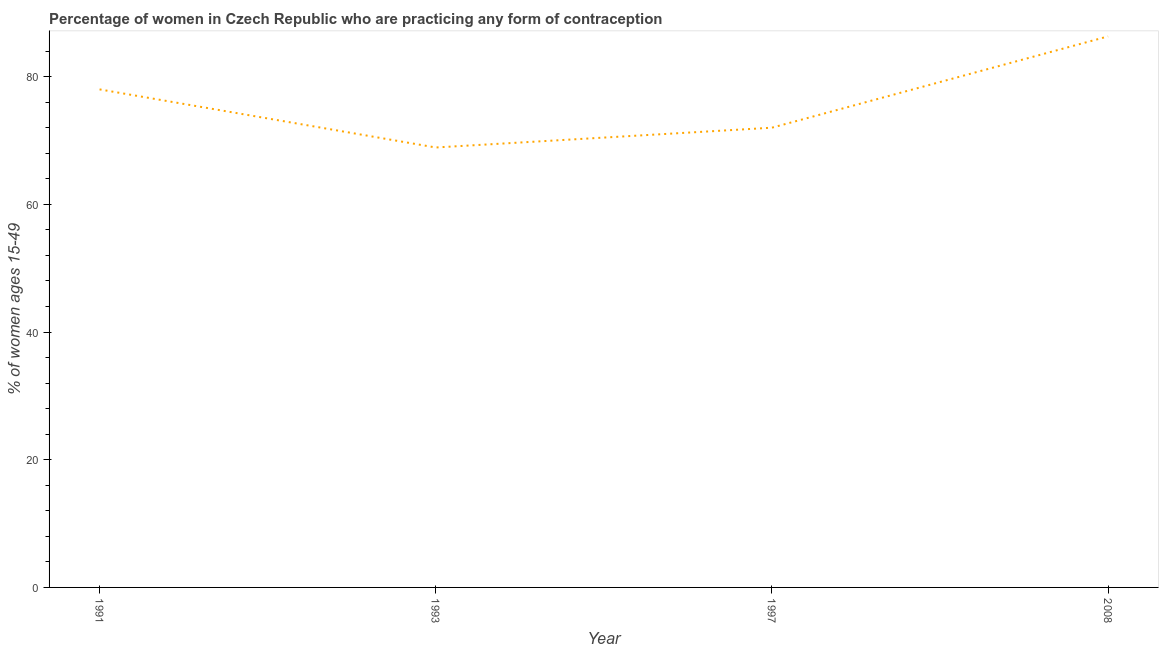What is the contraceptive prevalence in 1993?
Provide a short and direct response. 68.9. Across all years, what is the maximum contraceptive prevalence?
Ensure brevity in your answer.  86.3. Across all years, what is the minimum contraceptive prevalence?
Provide a short and direct response. 68.9. In which year was the contraceptive prevalence maximum?
Provide a short and direct response. 2008. What is the sum of the contraceptive prevalence?
Provide a succinct answer. 305.2. What is the average contraceptive prevalence per year?
Ensure brevity in your answer.  76.3. What is the median contraceptive prevalence?
Give a very brief answer. 75. Do a majority of the years between 1993 and 2008 (inclusive) have contraceptive prevalence greater than 24 %?
Your answer should be compact. Yes. What is the ratio of the contraceptive prevalence in 1991 to that in 2008?
Provide a succinct answer. 0.9. What is the difference between the highest and the second highest contraceptive prevalence?
Offer a very short reply. 8.3. What is the difference between the highest and the lowest contraceptive prevalence?
Your answer should be very brief. 17.4. In how many years, is the contraceptive prevalence greater than the average contraceptive prevalence taken over all years?
Offer a very short reply. 2. Does the contraceptive prevalence monotonically increase over the years?
Make the answer very short. No. How many lines are there?
Your answer should be compact. 1. Are the values on the major ticks of Y-axis written in scientific E-notation?
Your answer should be compact. No. Does the graph contain grids?
Your answer should be compact. No. What is the title of the graph?
Make the answer very short. Percentage of women in Czech Republic who are practicing any form of contraception. What is the label or title of the Y-axis?
Your answer should be compact. % of women ages 15-49. What is the % of women ages 15-49 of 1993?
Your answer should be very brief. 68.9. What is the % of women ages 15-49 in 2008?
Keep it short and to the point. 86.3. What is the difference between the % of women ages 15-49 in 1993 and 2008?
Your answer should be compact. -17.4. What is the difference between the % of women ages 15-49 in 1997 and 2008?
Keep it short and to the point. -14.3. What is the ratio of the % of women ages 15-49 in 1991 to that in 1993?
Your answer should be very brief. 1.13. What is the ratio of the % of women ages 15-49 in 1991 to that in 1997?
Make the answer very short. 1.08. What is the ratio of the % of women ages 15-49 in 1991 to that in 2008?
Offer a very short reply. 0.9. What is the ratio of the % of women ages 15-49 in 1993 to that in 2008?
Give a very brief answer. 0.8. What is the ratio of the % of women ages 15-49 in 1997 to that in 2008?
Ensure brevity in your answer.  0.83. 